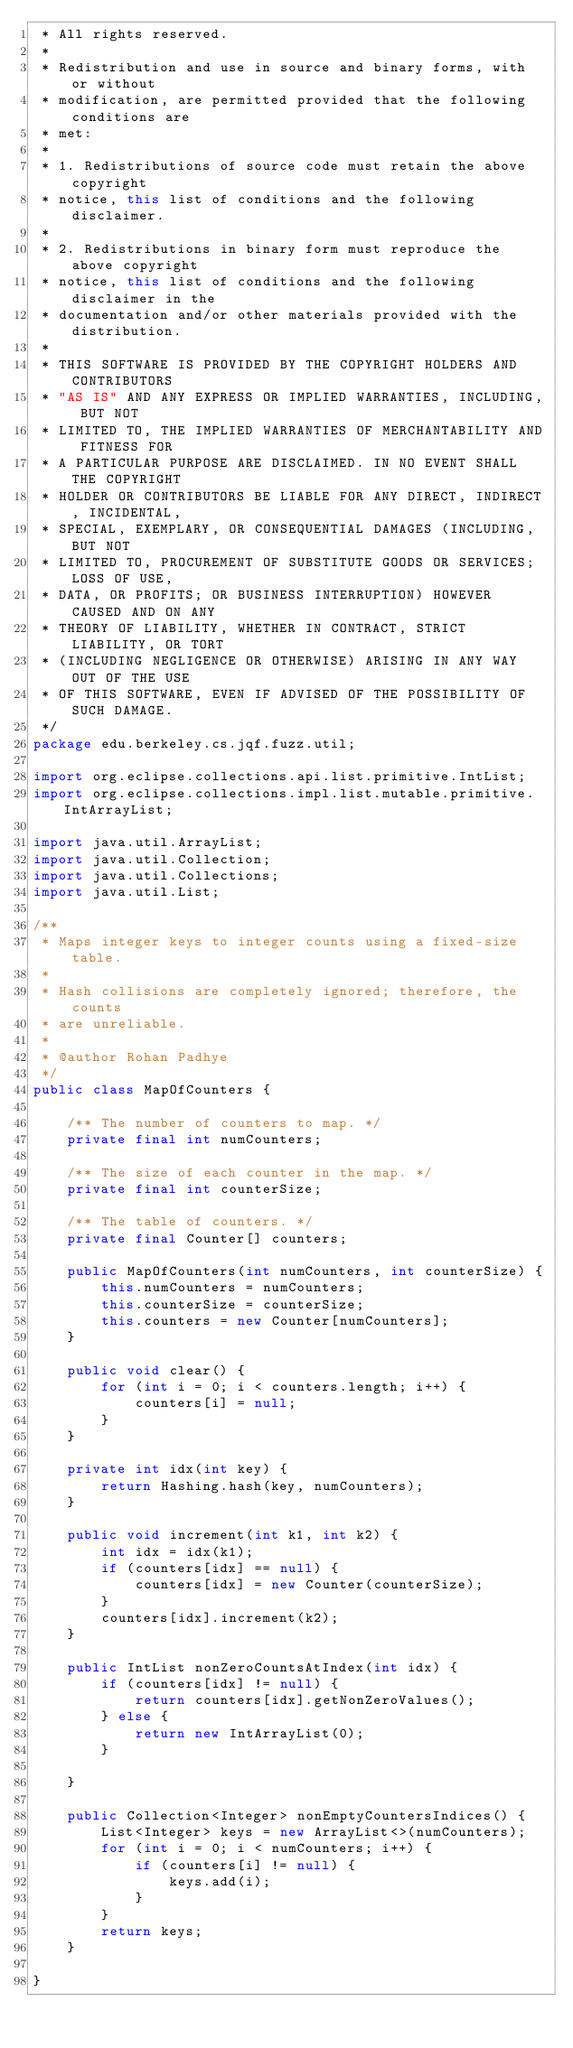<code> <loc_0><loc_0><loc_500><loc_500><_Java_> * All rights reserved.
 *
 * Redistribution and use in source and binary forms, with or without
 * modification, are permitted provided that the following conditions are
 * met:
 *
 * 1. Redistributions of source code must retain the above copyright
 * notice, this list of conditions and the following disclaimer.
 *
 * 2. Redistributions in binary form must reproduce the above copyright
 * notice, this list of conditions and the following disclaimer in the
 * documentation and/or other materials provided with the distribution.
 *
 * THIS SOFTWARE IS PROVIDED BY THE COPYRIGHT HOLDERS AND CONTRIBUTORS
 * "AS IS" AND ANY EXPRESS OR IMPLIED WARRANTIES, INCLUDING, BUT NOT
 * LIMITED TO, THE IMPLIED WARRANTIES OF MERCHANTABILITY AND FITNESS FOR
 * A PARTICULAR PURPOSE ARE DISCLAIMED. IN NO EVENT SHALL THE COPYRIGHT
 * HOLDER OR CONTRIBUTORS BE LIABLE FOR ANY DIRECT, INDIRECT, INCIDENTAL,
 * SPECIAL, EXEMPLARY, OR CONSEQUENTIAL DAMAGES (INCLUDING, BUT NOT
 * LIMITED TO, PROCUREMENT OF SUBSTITUTE GOODS OR SERVICES; LOSS OF USE,
 * DATA, OR PROFITS; OR BUSINESS INTERRUPTION) HOWEVER CAUSED AND ON ANY
 * THEORY OF LIABILITY, WHETHER IN CONTRACT, STRICT LIABILITY, OR TORT
 * (INCLUDING NEGLIGENCE OR OTHERWISE) ARISING IN ANY WAY OUT OF THE USE
 * OF THIS SOFTWARE, EVEN IF ADVISED OF THE POSSIBILITY OF SUCH DAMAGE.
 */
package edu.berkeley.cs.jqf.fuzz.util;

import org.eclipse.collections.api.list.primitive.IntList;
import org.eclipse.collections.impl.list.mutable.primitive.IntArrayList;

import java.util.ArrayList;
import java.util.Collection;
import java.util.Collections;
import java.util.List;

/**
 * Maps integer keys to integer counts using a fixed-size table.
 *
 * Hash collisions are completely ignored; therefore, the counts
 * are unreliable.
 *
 * @author Rohan Padhye
 */
public class MapOfCounters {

    /** The number of counters to map. */
    private final int numCounters;

    /** The size of each counter in the map. */
    private final int counterSize;

    /** The table of counters. */
    private final Counter[] counters;

    public MapOfCounters(int numCounters, int counterSize) {
        this.numCounters = numCounters;
        this.counterSize = counterSize;
        this.counters = new Counter[numCounters];
    }

    public void clear() {
        for (int i = 0; i < counters.length; i++) {
            counters[i] = null;
        }
    }

    private int idx(int key) {
        return Hashing.hash(key, numCounters);
    }

    public void increment(int k1, int k2) {
        int idx = idx(k1);
        if (counters[idx] == null) {
            counters[idx] = new Counter(counterSize);
        }
        counters[idx].increment(k2);
    }

    public IntList nonZeroCountsAtIndex(int idx) {
        if (counters[idx] != null) {
            return counters[idx].getNonZeroValues();
        } else {
            return new IntArrayList(0);
        }

    }

    public Collection<Integer> nonEmptyCountersIndices() {
        List<Integer> keys = new ArrayList<>(numCounters);
        for (int i = 0; i < numCounters; i++) {
            if (counters[i] != null) {
                keys.add(i);
            }
        }
        return keys;
    }

}
</code> 